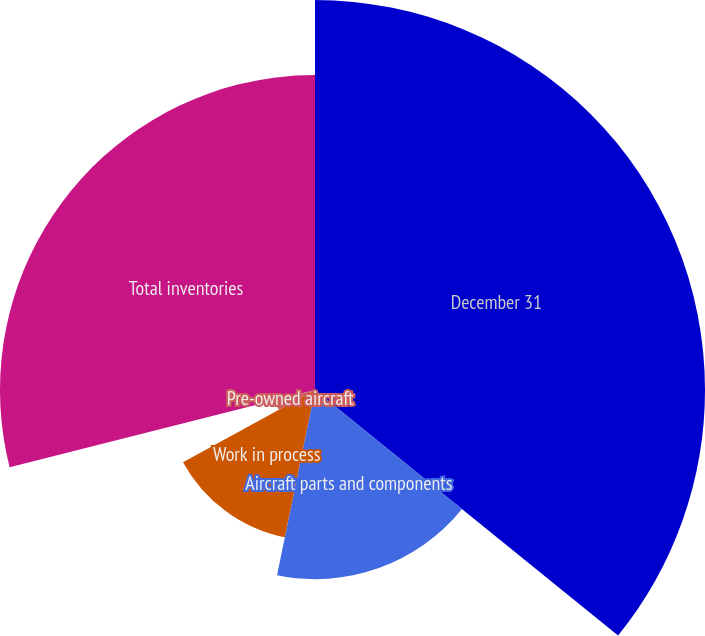Convert chart to OTSL. <chart><loc_0><loc_0><loc_500><loc_500><pie_chart><fcel>December 31<fcel>Aircraft parts and components<fcel>Work in process<fcel>Pre-owned aircraft<fcel>Other<fcel>Total inventories<nl><fcel>35.83%<fcel>17.38%<fcel>13.82%<fcel>3.79%<fcel>0.23%<fcel>28.94%<nl></chart> 